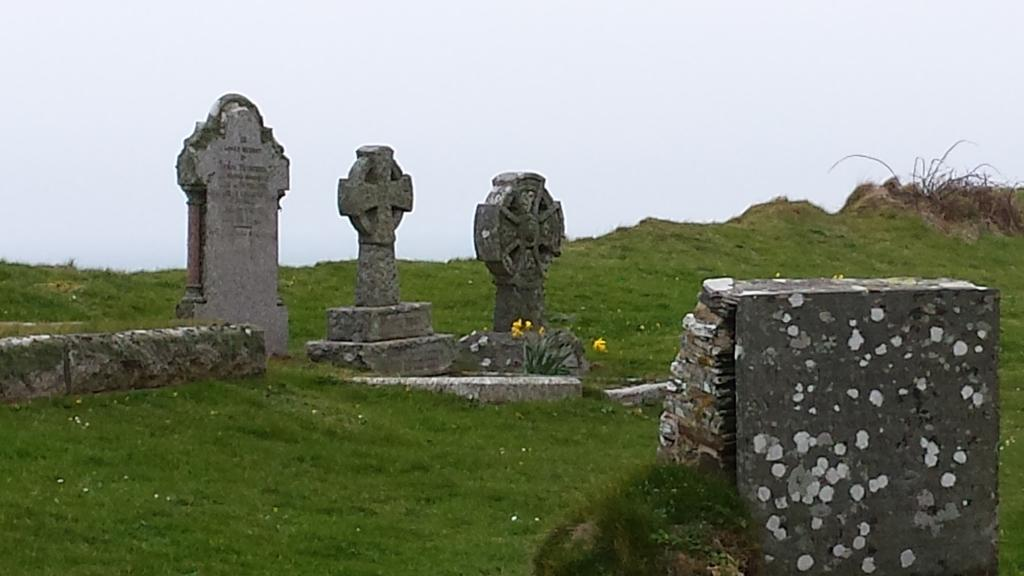What can be seen on the left side of the image? There is a stone carving on the left side of the image. What is located on the grass in the image? There are sculptures on the grass in the image. What type of plant is present in the image? There is a plant with flowers in the image. What is visible in the background of the image? The background of the image includes the sky. What is located on the right side of the image? There are stones on the right side of the image. What type of powder is being used to write on the stones in the image? There is no powder or writing present in the image; it features stone carvings and sculptures. Can you tell me the name of the parent sculpture in the image? There are no sculptures with a parent-child relationship depicted in the image. 